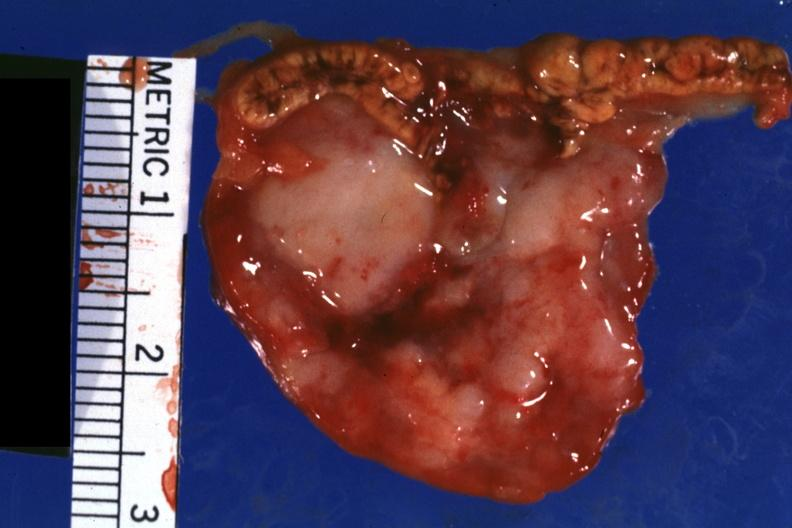s nodular tumor bloody?
Answer the question using a single word or phrase. No 